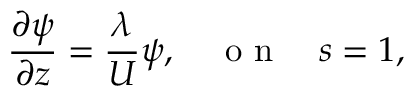Convert formula to latex. <formula><loc_0><loc_0><loc_500><loc_500>\frac { \partial \psi } { \partial z } = \frac { \lambda } { U } \psi , \quad o n \quad s = 1 ,</formula> 